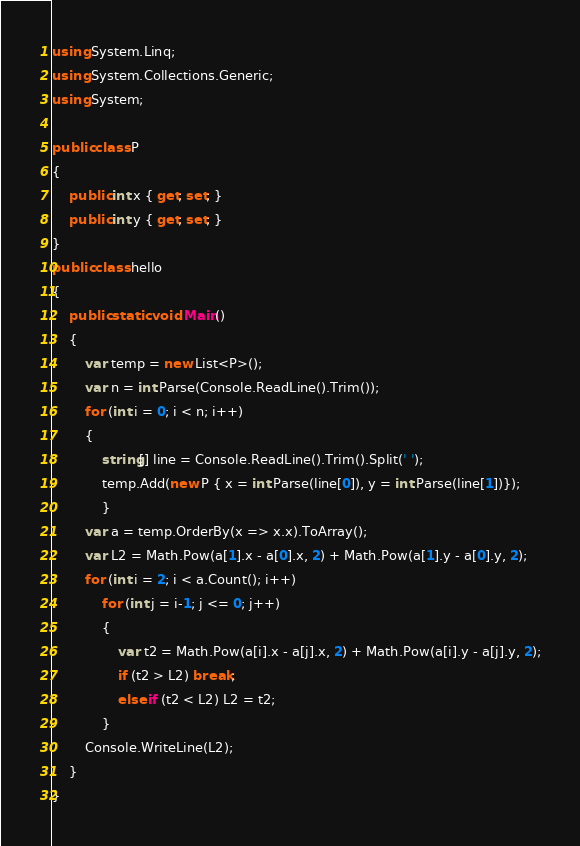<code> <loc_0><loc_0><loc_500><loc_500><_C#_>using System.Linq;
using System.Collections.Generic;
using System;

public class P
{
    public int x { get; set; }
    public int y { get; set; }
}
public class hello
{
    public static void Main()
    {
        var temp = new List<P>();
        var n = int.Parse(Console.ReadLine().Trim());
        for (int i = 0; i < n; i++) 
        {
            string[] line = Console.ReadLine().Trim().Split(' ');
            temp.Add(new P { x = int.Parse(line[0]), y = int.Parse(line[1])});
            }
        var a = temp.OrderBy(x => x.x).ToArray();
        var L2 = Math.Pow(a[1].x - a[0].x, 2) + Math.Pow(a[1].y - a[0].y, 2);
        for (int i = 2; i < a.Count(); i++)
            for (int j = i-1; j <= 0; j++)
            {
                var t2 = Math.Pow(a[i].x - a[j].x, 2) + Math.Pow(a[i].y - a[j].y, 2);
                if (t2 > L2) break;
                else if (t2 < L2) L2 = t2;
            }
        Console.WriteLine(L2);
    }
}</code> 